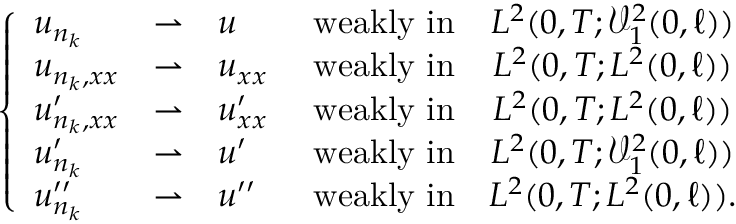Convert formula to latex. <formula><loc_0><loc_0><loc_500><loc_500>\begin{array} { r } { \left \{ \begin{array} { l c l c c l } { u _ { n _ { k } } } & { \rightharpoonup } & { u \ } & { w e a k l y i n } & { L ^ { 2 } ( 0 , T ; \mathcal { V } _ { 1 } ^ { 2 } ( 0 , \ell ) ) } \\ { u _ { n _ { k } , x x } } & { \rightharpoonup } & { u _ { x x } \ } & { w e a k l y i n } & { L ^ { 2 } ( 0 , T ; L ^ { 2 } ( 0 , \ell ) ) } \\ { u _ { n _ { k } , x x } ^ { \prime } } & { \rightharpoonup } & { u _ { x x } ^ { \prime } \ } & { w e a k l y i n } & { L ^ { 2 } ( 0 , T ; L ^ { 2 } ( 0 , \ell ) ) } \\ { u _ { n _ { k } } ^ { \prime } } & { \rightharpoonup } & { u ^ { \prime } \ } & { w e a k l y i n } & { L ^ { 2 } ( 0 , T ; \mathcal { V } _ { 1 } ^ { 2 } ( 0 , \ell ) ) } \\ { u _ { n _ { k } } ^ { \prime \prime } } & { \rightharpoonup } & { u ^ { \prime \prime } \ } & { w e a k l y i n } & { L ^ { 2 } ( 0 , T ; L ^ { 2 } ( 0 , \ell ) ) . } \end{array} } \end{array}</formula> 